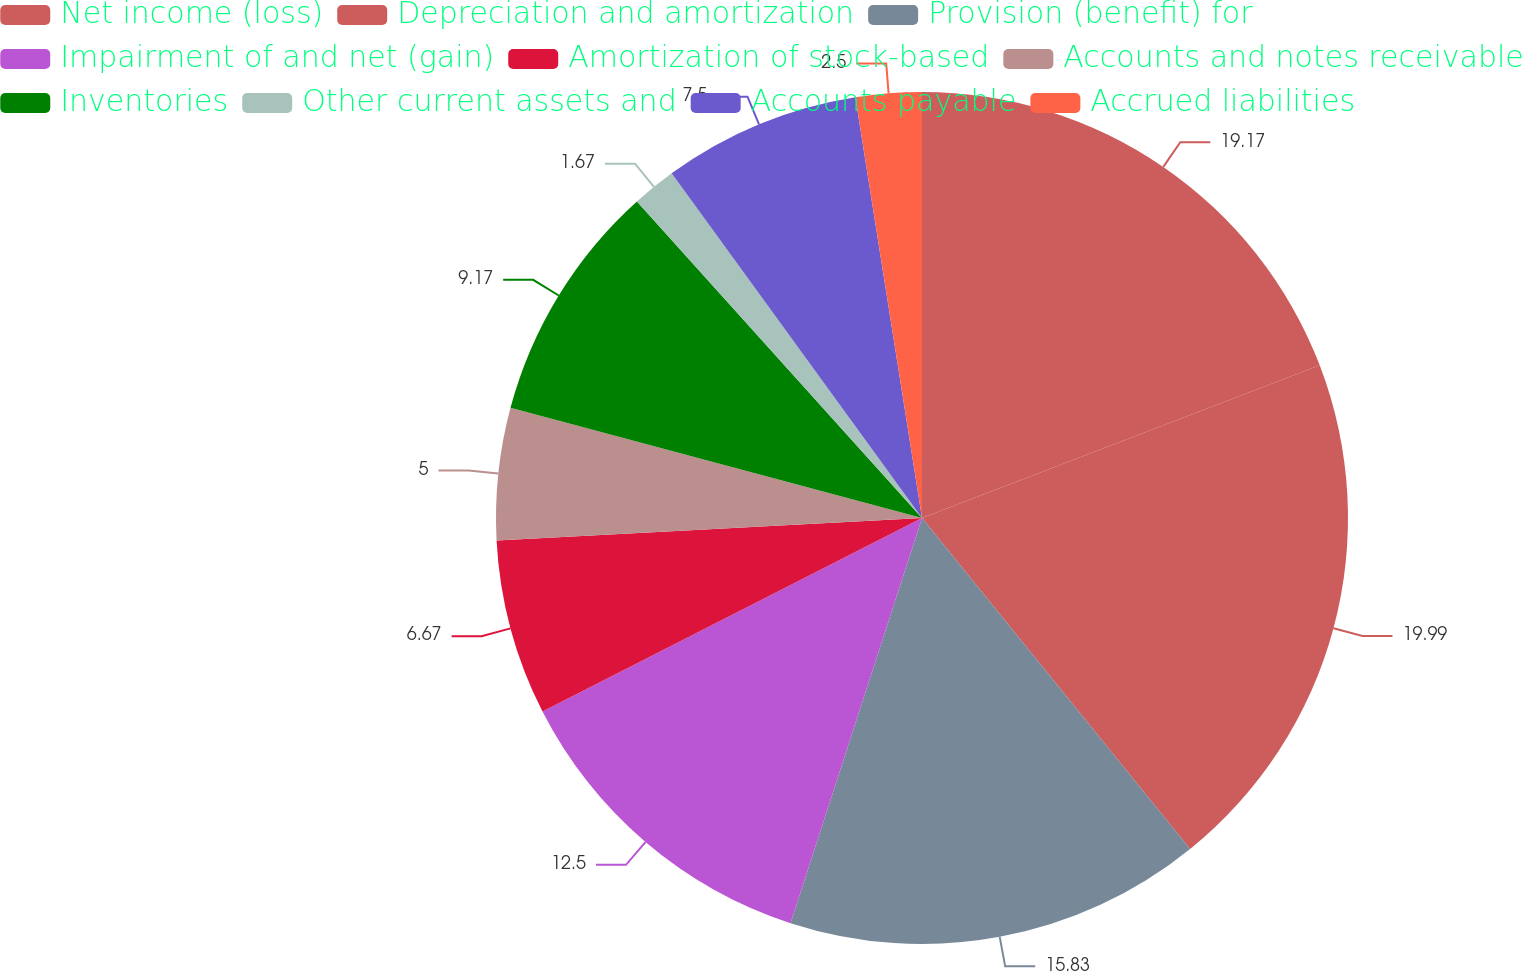<chart> <loc_0><loc_0><loc_500><loc_500><pie_chart><fcel>Net income (loss)<fcel>Depreciation and amortization<fcel>Provision (benefit) for<fcel>Impairment of and net (gain)<fcel>Amortization of stock-based<fcel>Accounts and notes receivable<fcel>Inventories<fcel>Other current assets and<fcel>Accounts payable<fcel>Accrued liabilities<nl><fcel>19.17%<fcel>20.0%<fcel>15.83%<fcel>12.5%<fcel>6.67%<fcel>5.0%<fcel>9.17%<fcel>1.67%<fcel>7.5%<fcel>2.5%<nl></chart> 